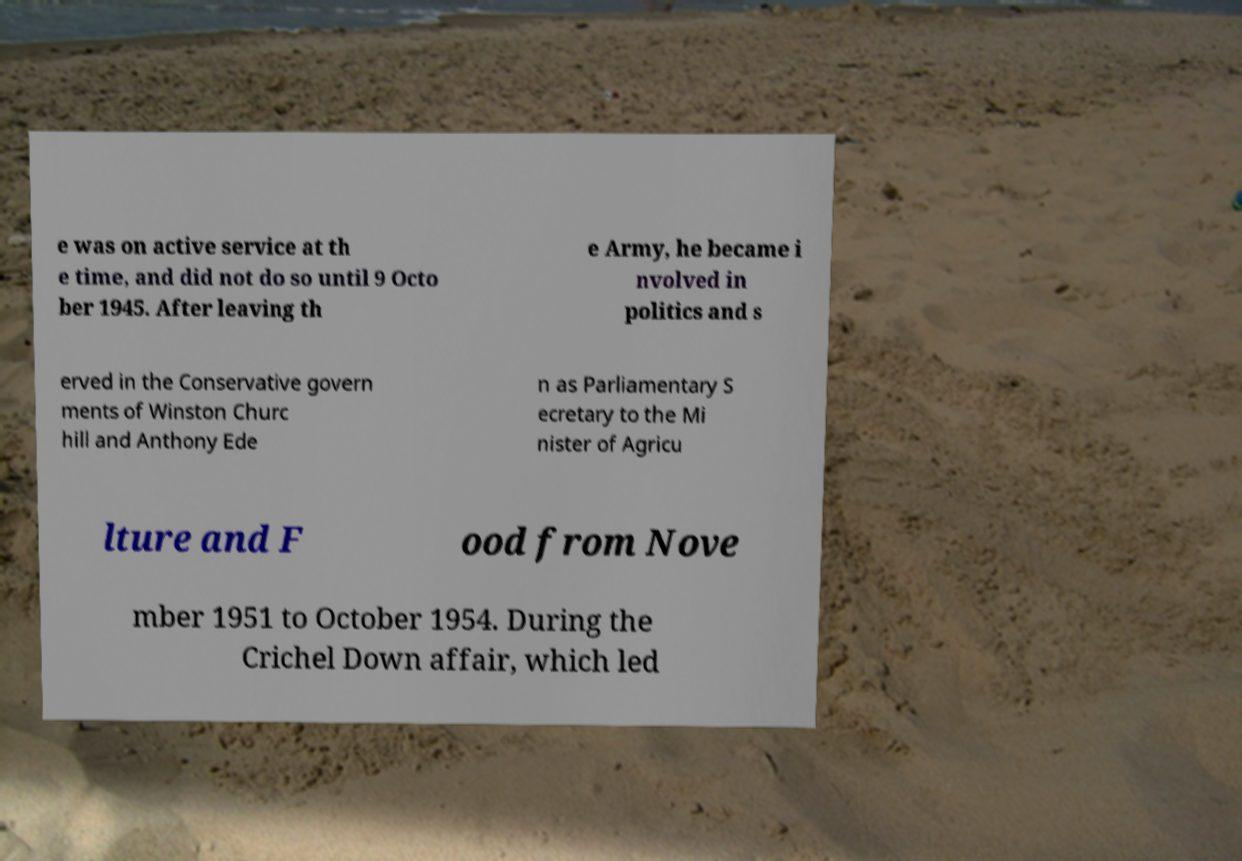Could you extract and type out the text from this image? e was on active service at th e time, and did not do so until 9 Octo ber 1945. After leaving th e Army, he became i nvolved in politics and s erved in the Conservative govern ments of Winston Churc hill and Anthony Ede n as Parliamentary S ecretary to the Mi nister of Agricu lture and F ood from Nove mber 1951 to October 1954. During the Crichel Down affair, which led 